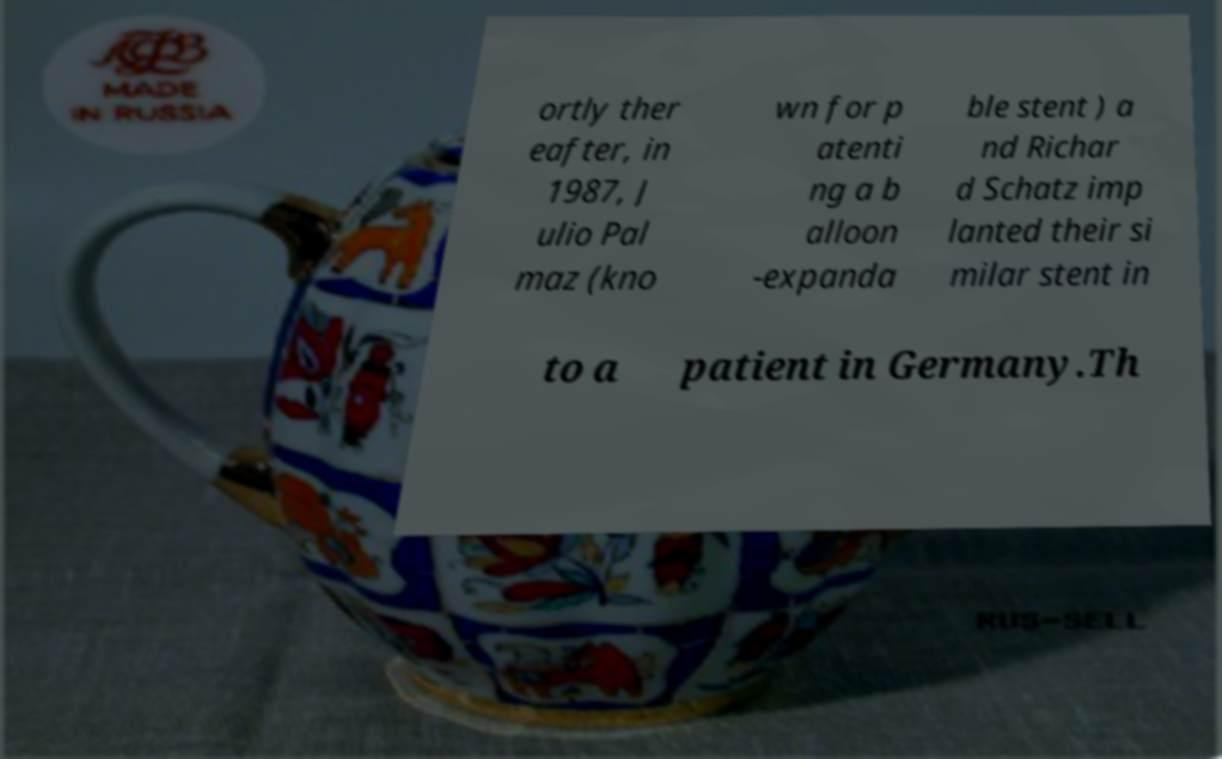For documentation purposes, I need the text within this image transcribed. Could you provide that? ortly ther eafter, in 1987, J ulio Pal maz (kno wn for p atenti ng a b alloon -expanda ble stent ) a nd Richar d Schatz imp lanted their si milar stent in to a patient in Germany.Th 